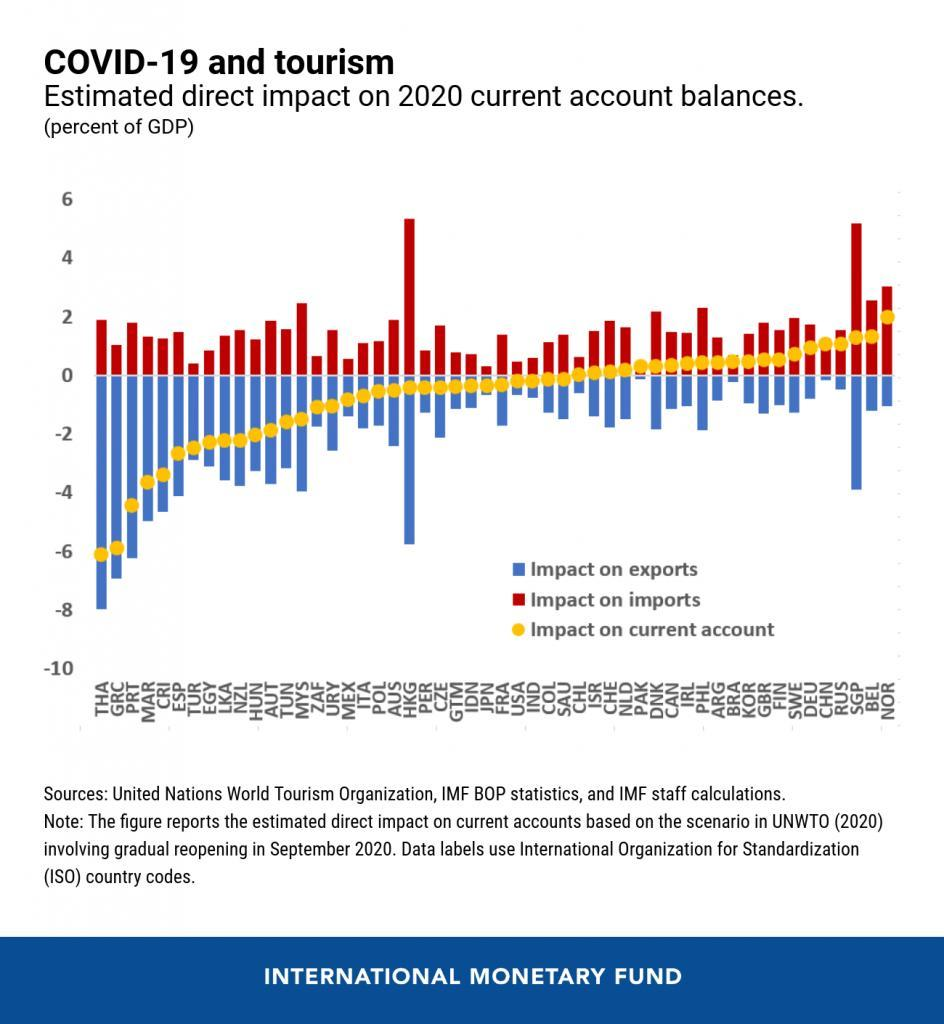Which colour is used to represent impact on exports- blue, red or yellow?
Answer the question with a short phrase. Blue Which country has the highest positive impact on current account? NOR In which two countries where the the impact on imports the highest? HKG, SGP 